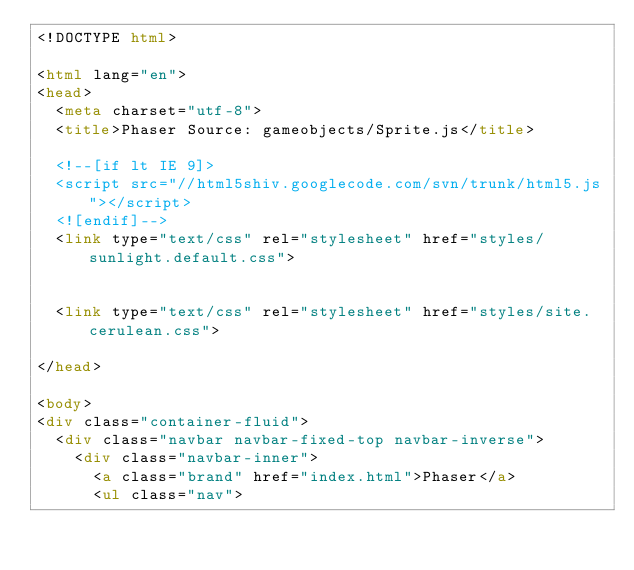<code> <loc_0><loc_0><loc_500><loc_500><_HTML_><!DOCTYPE html>

<html lang="en">
<head>
	<meta charset="utf-8">
	<title>Phaser Source: gameobjects/Sprite.js</title>

	<!--[if lt IE 9]>
	<script src="//html5shiv.googlecode.com/svn/trunk/html5.js"></script>
	<![endif]-->
	<link type="text/css" rel="stylesheet" href="styles/sunlight.default.css">

	
	<link type="text/css" rel="stylesheet" href="styles/site.cerulean.css">
	
</head>

<body>
<div class="container-fluid">
	<div class="navbar navbar-fixed-top navbar-inverse">
		<div class="navbar-inner">
			<a class="brand" href="index.html">Phaser</a>
			<ul class="nav">
				</code> 